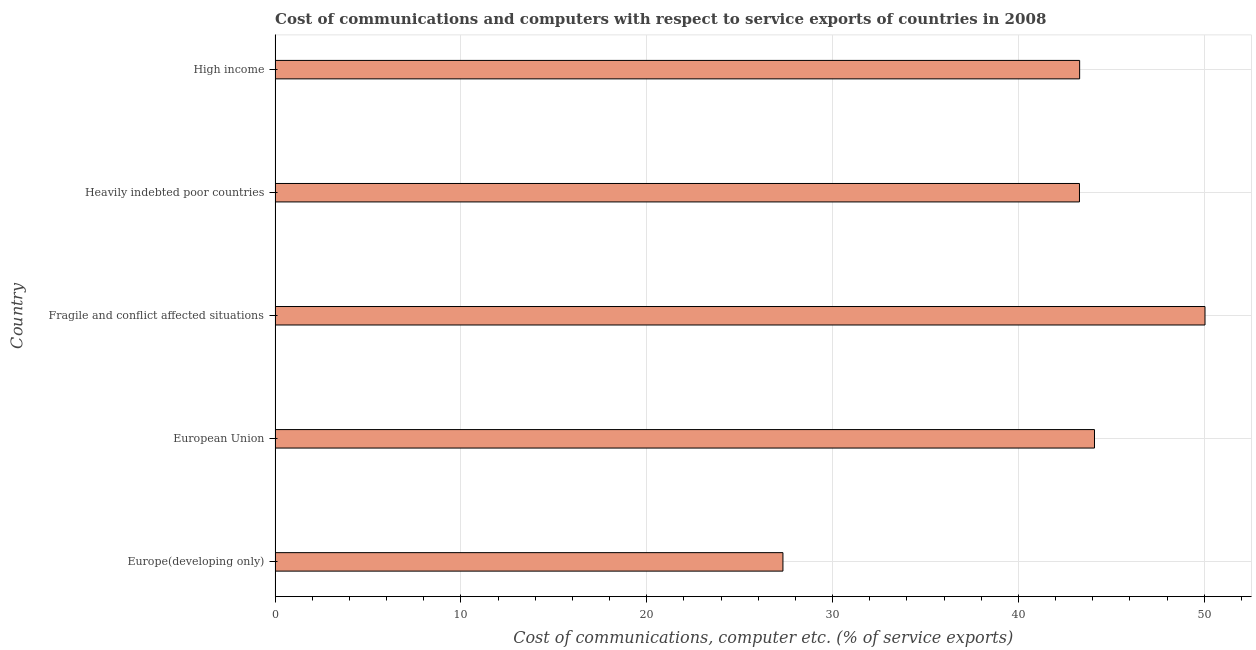Does the graph contain any zero values?
Ensure brevity in your answer.  No. Does the graph contain grids?
Keep it short and to the point. Yes. What is the title of the graph?
Keep it short and to the point. Cost of communications and computers with respect to service exports of countries in 2008. What is the label or title of the X-axis?
Your answer should be very brief. Cost of communications, computer etc. (% of service exports). What is the cost of communications and computer in Heavily indebted poor countries?
Your response must be concise. 43.29. Across all countries, what is the maximum cost of communications and computer?
Give a very brief answer. 50.04. Across all countries, what is the minimum cost of communications and computer?
Keep it short and to the point. 27.33. In which country was the cost of communications and computer maximum?
Provide a succinct answer. Fragile and conflict affected situations. In which country was the cost of communications and computer minimum?
Your answer should be compact. Europe(developing only). What is the sum of the cost of communications and computer?
Offer a terse response. 208.05. What is the difference between the cost of communications and computer in Europe(developing only) and European Union?
Provide a short and direct response. -16.77. What is the average cost of communications and computer per country?
Keep it short and to the point. 41.61. What is the median cost of communications and computer?
Give a very brief answer. 43.3. In how many countries, is the cost of communications and computer greater than 50 %?
Your answer should be compact. 1. What is the ratio of the cost of communications and computer in Fragile and conflict affected situations to that in Heavily indebted poor countries?
Keep it short and to the point. 1.16. Is the difference between the cost of communications and computer in Europe(developing only) and Fragile and conflict affected situations greater than the difference between any two countries?
Your answer should be compact. Yes. What is the difference between the highest and the second highest cost of communications and computer?
Your answer should be compact. 5.95. Is the sum of the cost of communications and computer in European Union and High income greater than the maximum cost of communications and computer across all countries?
Offer a terse response. Yes. What is the difference between the highest and the lowest cost of communications and computer?
Give a very brief answer. 22.71. How many bars are there?
Provide a succinct answer. 5. How many countries are there in the graph?
Offer a terse response. 5. What is the difference between two consecutive major ticks on the X-axis?
Provide a succinct answer. 10. What is the Cost of communications, computer etc. (% of service exports) of Europe(developing only)?
Your response must be concise. 27.33. What is the Cost of communications, computer etc. (% of service exports) in European Union?
Your answer should be compact. 44.09. What is the Cost of communications, computer etc. (% of service exports) in Fragile and conflict affected situations?
Your answer should be compact. 50.04. What is the Cost of communications, computer etc. (% of service exports) of Heavily indebted poor countries?
Offer a very short reply. 43.29. What is the Cost of communications, computer etc. (% of service exports) in High income?
Keep it short and to the point. 43.3. What is the difference between the Cost of communications, computer etc. (% of service exports) in Europe(developing only) and European Union?
Your answer should be very brief. -16.77. What is the difference between the Cost of communications, computer etc. (% of service exports) in Europe(developing only) and Fragile and conflict affected situations?
Your response must be concise. -22.71. What is the difference between the Cost of communications, computer etc. (% of service exports) in Europe(developing only) and Heavily indebted poor countries?
Offer a very short reply. -15.96. What is the difference between the Cost of communications, computer etc. (% of service exports) in Europe(developing only) and High income?
Provide a succinct answer. -15.97. What is the difference between the Cost of communications, computer etc. (% of service exports) in European Union and Fragile and conflict affected situations?
Ensure brevity in your answer.  -5.95. What is the difference between the Cost of communications, computer etc. (% of service exports) in European Union and Heavily indebted poor countries?
Make the answer very short. 0.81. What is the difference between the Cost of communications, computer etc. (% of service exports) in European Union and High income?
Your answer should be very brief. 0.8. What is the difference between the Cost of communications, computer etc. (% of service exports) in Fragile and conflict affected situations and Heavily indebted poor countries?
Give a very brief answer. 6.75. What is the difference between the Cost of communications, computer etc. (% of service exports) in Fragile and conflict affected situations and High income?
Ensure brevity in your answer.  6.75. What is the difference between the Cost of communications, computer etc. (% of service exports) in Heavily indebted poor countries and High income?
Give a very brief answer. -0.01. What is the ratio of the Cost of communications, computer etc. (% of service exports) in Europe(developing only) to that in European Union?
Your answer should be very brief. 0.62. What is the ratio of the Cost of communications, computer etc. (% of service exports) in Europe(developing only) to that in Fragile and conflict affected situations?
Give a very brief answer. 0.55. What is the ratio of the Cost of communications, computer etc. (% of service exports) in Europe(developing only) to that in Heavily indebted poor countries?
Give a very brief answer. 0.63. What is the ratio of the Cost of communications, computer etc. (% of service exports) in Europe(developing only) to that in High income?
Give a very brief answer. 0.63. What is the ratio of the Cost of communications, computer etc. (% of service exports) in European Union to that in Fragile and conflict affected situations?
Your answer should be compact. 0.88. What is the ratio of the Cost of communications, computer etc. (% of service exports) in European Union to that in High income?
Offer a very short reply. 1.02. What is the ratio of the Cost of communications, computer etc. (% of service exports) in Fragile and conflict affected situations to that in Heavily indebted poor countries?
Offer a very short reply. 1.16. What is the ratio of the Cost of communications, computer etc. (% of service exports) in Fragile and conflict affected situations to that in High income?
Provide a short and direct response. 1.16. 